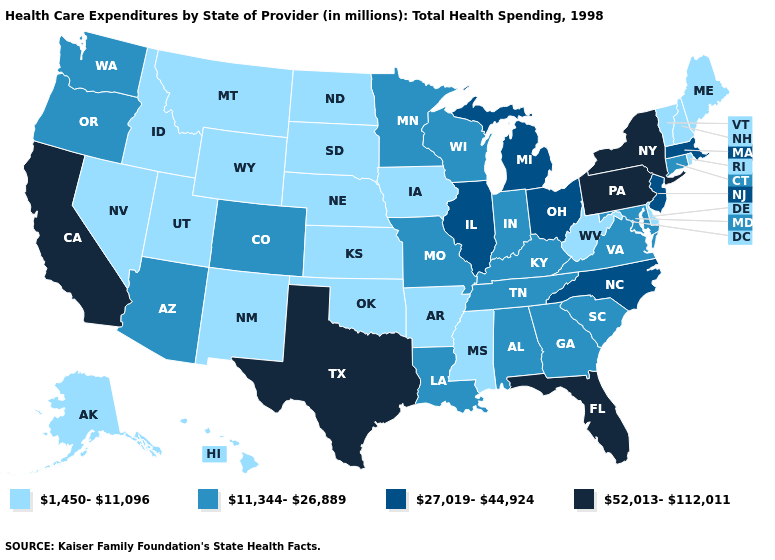Is the legend a continuous bar?
Answer briefly. No. What is the lowest value in the USA?
Keep it brief. 1,450-11,096. What is the highest value in states that border Arizona?
Answer briefly. 52,013-112,011. Among the states that border New Hampshire , does Massachusetts have the highest value?
Be succinct. Yes. What is the value of Iowa?
Quick response, please. 1,450-11,096. Name the states that have a value in the range 11,344-26,889?
Write a very short answer. Alabama, Arizona, Colorado, Connecticut, Georgia, Indiana, Kentucky, Louisiana, Maryland, Minnesota, Missouri, Oregon, South Carolina, Tennessee, Virginia, Washington, Wisconsin. Which states have the highest value in the USA?
Concise answer only. California, Florida, New York, Pennsylvania, Texas. Name the states that have a value in the range 1,450-11,096?
Keep it brief. Alaska, Arkansas, Delaware, Hawaii, Idaho, Iowa, Kansas, Maine, Mississippi, Montana, Nebraska, Nevada, New Hampshire, New Mexico, North Dakota, Oklahoma, Rhode Island, South Dakota, Utah, Vermont, West Virginia, Wyoming. What is the value of Maryland?
Write a very short answer. 11,344-26,889. Does the map have missing data?
Quick response, please. No. Does Connecticut have a lower value than Pennsylvania?
Give a very brief answer. Yes. Which states have the highest value in the USA?
Be succinct. California, Florida, New York, Pennsylvania, Texas. Among the states that border North Dakota , which have the highest value?
Be succinct. Minnesota. Does Alaska have the same value as Iowa?
Answer briefly. Yes. 